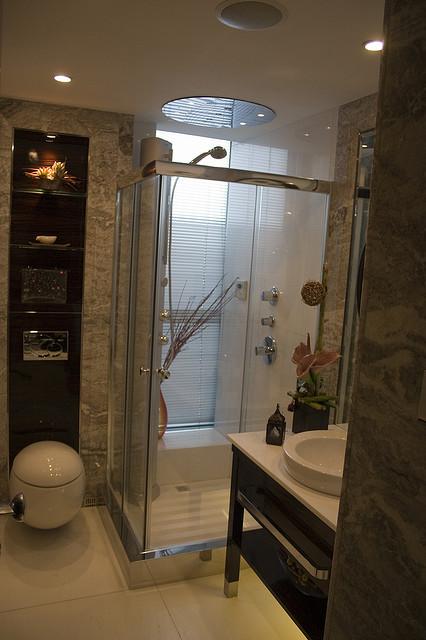Where is this scene?
Concise answer only. Bathroom. Where is the vase?
Keep it brief. On sink. What is surrounding the shower?
Give a very brief answer. Glass. What is the wall made of?
Keep it brief. Marble. What kind of room is this?
Answer briefly. Bathroom. 